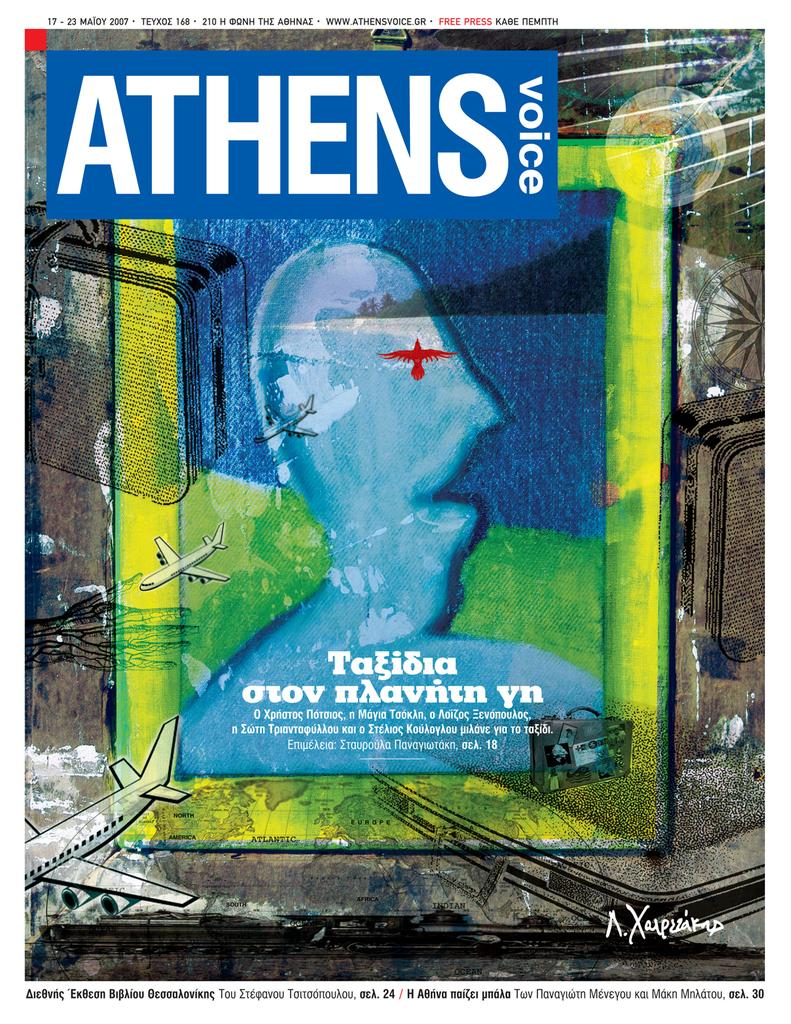<image>
Describe the image concisely. A digital print of the Athens Voice magazine cover from 2007. 